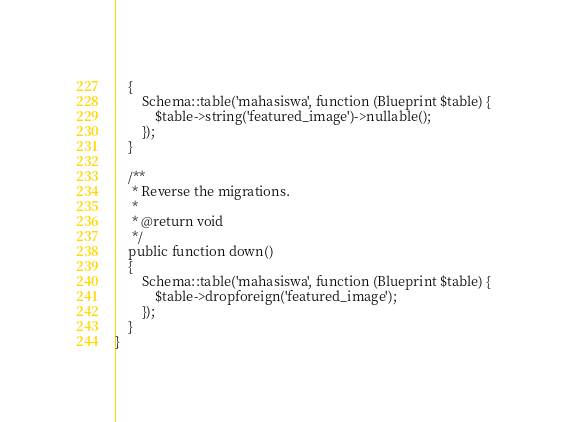<code> <loc_0><loc_0><loc_500><loc_500><_PHP_>    {
        Schema::table('mahasiswa', function (Blueprint $table) {
            $table->string('featured_image')->nullable();
        });
    }

    /**
     * Reverse the migrations.
     *
     * @return void
     */
    public function down()
    {
        Schema::table('mahasiswa', function (Blueprint $table) {
            $table->dropforeign('featured_image');
        });
    }
}
</code> 